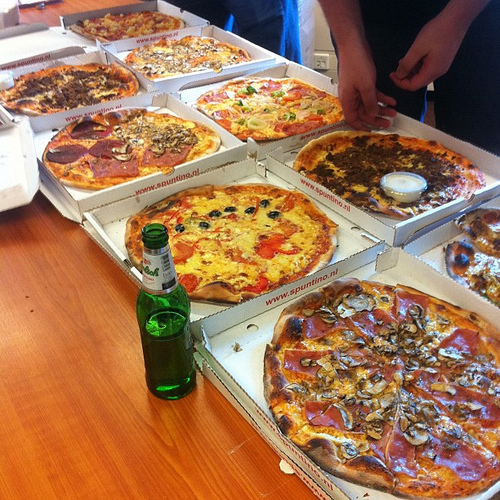Is there any hamburger in the photo? No, there is no hamburger in the photo. 